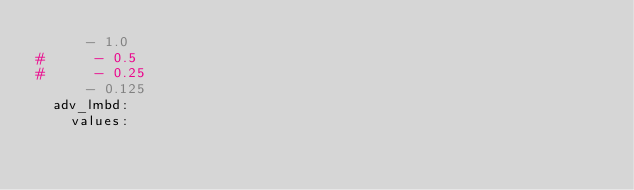<code> <loc_0><loc_0><loc_500><loc_500><_YAML_>      - 1.0
#      - 0.5
#      - 0.25
      - 0.125
  adv_lmbd:
    values:</code> 